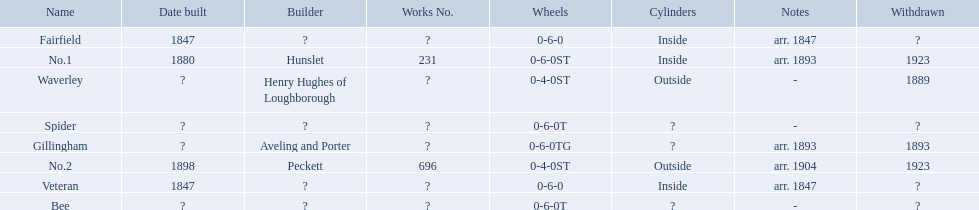What are the aldernay railways? Veteran, Fairfield, Waverley, Bee, Spider, Gillingham, No.1, No.2. Which ones were built in 1847? Veteran, Fairfield. Of those, which one is not fairfield? Veteran. 